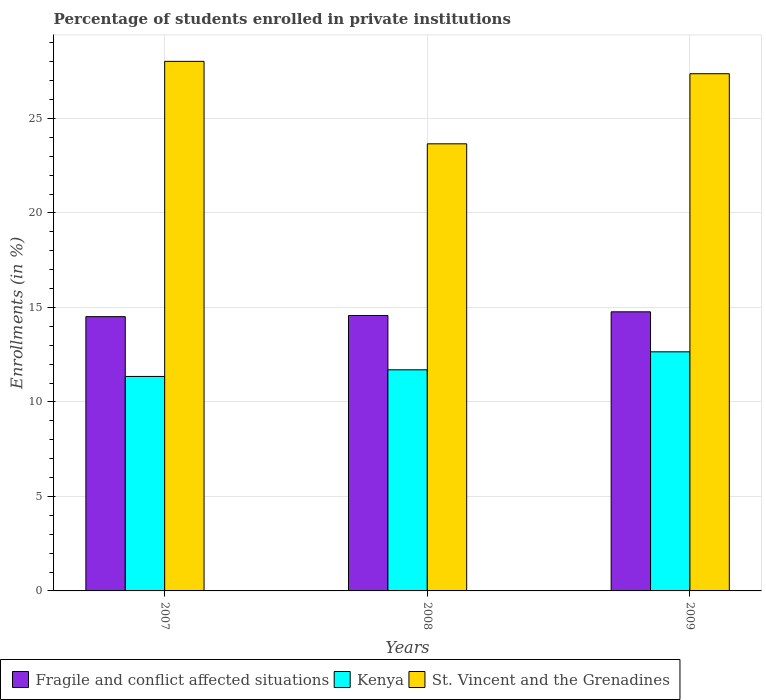How many different coloured bars are there?
Your answer should be very brief. 3. How many groups of bars are there?
Make the answer very short. 3. What is the label of the 2nd group of bars from the left?
Offer a terse response. 2008. What is the percentage of trained teachers in Kenya in 2008?
Ensure brevity in your answer.  11.7. Across all years, what is the maximum percentage of trained teachers in St. Vincent and the Grenadines?
Give a very brief answer. 28.02. Across all years, what is the minimum percentage of trained teachers in Kenya?
Your answer should be very brief. 11.35. In which year was the percentage of trained teachers in Fragile and conflict affected situations maximum?
Offer a terse response. 2009. In which year was the percentage of trained teachers in St. Vincent and the Grenadines minimum?
Offer a terse response. 2008. What is the total percentage of trained teachers in Fragile and conflict affected situations in the graph?
Ensure brevity in your answer.  43.85. What is the difference between the percentage of trained teachers in Fragile and conflict affected situations in 2008 and that in 2009?
Provide a short and direct response. -0.2. What is the difference between the percentage of trained teachers in Kenya in 2008 and the percentage of trained teachers in St. Vincent and the Grenadines in 2009?
Make the answer very short. -15.67. What is the average percentage of trained teachers in Kenya per year?
Offer a very short reply. 11.9. In the year 2009, what is the difference between the percentage of trained teachers in St. Vincent and the Grenadines and percentage of trained teachers in Fragile and conflict affected situations?
Provide a short and direct response. 12.6. What is the ratio of the percentage of trained teachers in Kenya in 2007 to that in 2009?
Provide a short and direct response. 0.9. Is the percentage of trained teachers in St. Vincent and the Grenadines in 2008 less than that in 2009?
Give a very brief answer. Yes. Is the difference between the percentage of trained teachers in St. Vincent and the Grenadines in 2007 and 2008 greater than the difference between the percentage of trained teachers in Fragile and conflict affected situations in 2007 and 2008?
Keep it short and to the point. Yes. What is the difference between the highest and the second highest percentage of trained teachers in Fragile and conflict affected situations?
Provide a succinct answer. 0.2. What is the difference between the highest and the lowest percentage of trained teachers in St. Vincent and the Grenadines?
Provide a succinct answer. 4.36. What does the 3rd bar from the left in 2009 represents?
Make the answer very short. St. Vincent and the Grenadines. What does the 3rd bar from the right in 2009 represents?
Give a very brief answer. Fragile and conflict affected situations. Is it the case that in every year, the sum of the percentage of trained teachers in Fragile and conflict affected situations and percentage of trained teachers in Kenya is greater than the percentage of trained teachers in St. Vincent and the Grenadines?
Give a very brief answer. No. How many bars are there?
Ensure brevity in your answer.  9. How many years are there in the graph?
Your answer should be compact. 3. Where does the legend appear in the graph?
Offer a terse response. Bottom left. How many legend labels are there?
Your answer should be compact. 3. How are the legend labels stacked?
Give a very brief answer. Horizontal. What is the title of the graph?
Provide a succinct answer. Percentage of students enrolled in private institutions. What is the label or title of the Y-axis?
Make the answer very short. Enrollments (in %). What is the Enrollments (in %) in Fragile and conflict affected situations in 2007?
Your answer should be compact. 14.51. What is the Enrollments (in %) of Kenya in 2007?
Offer a very short reply. 11.35. What is the Enrollments (in %) of St. Vincent and the Grenadines in 2007?
Your answer should be very brief. 28.02. What is the Enrollments (in %) of Fragile and conflict affected situations in 2008?
Offer a very short reply. 14.57. What is the Enrollments (in %) in Kenya in 2008?
Provide a succinct answer. 11.7. What is the Enrollments (in %) of St. Vincent and the Grenadines in 2008?
Keep it short and to the point. 23.66. What is the Enrollments (in %) in Fragile and conflict affected situations in 2009?
Your response must be concise. 14.77. What is the Enrollments (in %) in Kenya in 2009?
Make the answer very short. 12.65. What is the Enrollments (in %) of St. Vincent and the Grenadines in 2009?
Give a very brief answer. 27.37. Across all years, what is the maximum Enrollments (in %) of Fragile and conflict affected situations?
Your answer should be compact. 14.77. Across all years, what is the maximum Enrollments (in %) of Kenya?
Offer a terse response. 12.65. Across all years, what is the maximum Enrollments (in %) of St. Vincent and the Grenadines?
Offer a terse response. 28.02. Across all years, what is the minimum Enrollments (in %) in Fragile and conflict affected situations?
Offer a very short reply. 14.51. Across all years, what is the minimum Enrollments (in %) in Kenya?
Provide a succinct answer. 11.35. Across all years, what is the minimum Enrollments (in %) in St. Vincent and the Grenadines?
Provide a succinct answer. 23.66. What is the total Enrollments (in %) in Fragile and conflict affected situations in the graph?
Give a very brief answer. 43.85. What is the total Enrollments (in %) in Kenya in the graph?
Provide a succinct answer. 35.7. What is the total Enrollments (in %) of St. Vincent and the Grenadines in the graph?
Offer a terse response. 79.05. What is the difference between the Enrollments (in %) of Fragile and conflict affected situations in 2007 and that in 2008?
Ensure brevity in your answer.  -0.06. What is the difference between the Enrollments (in %) of Kenya in 2007 and that in 2008?
Provide a short and direct response. -0.35. What is the difference between the Enrollments (in %) of St. Vincent and the Grenadines in 2007 and that in 2008?
Your answer should be very brief. 4.36. What is the difference between the Enrollments (in %) in Fragile and conflict affected situations in 2007 and that in 2009?
Your response must be concise. -0.26. What is the difference between the Enrollments (in %) of Kenya in 2007 and that in 2009?
Your answer should be compact. -1.3. What is the difference between the Enrollments (in %) of St. Vincent and the Grenadines in 2007 and that in 2009?
Make the answer very short. 0.65. What is the difference between the Enrollments (in %) of Fragile and conflict affected situations in 2008 and that in 2009?
Provide a short and direct response. -0.2. What is the difference between the Enrollments (in %) of Kenya in 2008 and that in 2009?
Offer a terse response. -0.95. What is the difference between the Enrollments (in %) in St. Vincent and the Grenadines in 2008 and that in 2009?
Your answer should be compact. -3.71. What is the difference between the Enrollments (in %) of Fragile and conflict affected situations in 2007 and the Enrollments (in %) of Kenya in 2008?
Make the answer very short. 2.81. What is the difference between the Enrollments (in %) in Fragile and conflict affected situations in 2007 and the Enrollments (in %) in St. Vincent and the Grenadines in 2008?
Provide a succinct answer. -9.15. What is the difference between the Enrollments (in %) of Kenya in 2007 and the Enrollments (in %) of St. Vincent and the Grenadines in 2008?
Give a very brief answer. -12.31. What is the difference between the Enrollments (in %) in Fragile and conflict affected situations in 2007 and the Enrollments (in %) in Kenya in 2009?
Keep it short and to the point. 1.86. What is the difference between the Enrollments (in %) of Fragile and conflict affected situations in 2007 and the Enrollments (in %) of St. Vincent and the Grenadines in 2009?
Ensure brevity in your answer.  -12.85. What is the difference between the Enrollments (in %) in Kenya in 2007 and the Enrollments (in %) in St. Vincent and the Grenadines in 2009?
Give a very brief answer. -16.02. What is the difference between the Enrollments (in %) of Fragile and conflict affected situations in 2008 and the Enrollments (in %) of Kenya in 2009?
Give a very brief answer. 1.92. What is the difference between the Enrollments (in %) in Fragile and conflict affected situations in 2008 and the Enrollments (in %) in St. Vincent and the Grenadines in 2009?
Make the answer very short. -12.79. What is the difference between the Enrollments (in %) of Kenya in 2008 and the Enrollments (in %) of St. Vincent and the Grenadines in 2009?
Keep it short and to the point. -15.67. What is the average Enrollments (in %) in Fragile and conflict affected situations per year?
Offer a very short reply. 14.62. What is the average Enrollments (in %) of Kenya per year?
Offer a terse response. 11.9. What is the average Enrollments (in %) in St. Vincent and the Grenadines per year?
Offer a terse response. 26.35. In the year 2007, what is the difference between the Enrollments (in %) of Fragile and conflict affected situations and Enrollments (in %) of Kenya?
Make the answer very short. 3.16. In the year 2007, what is the difference between the Enrollments (in %) of Fragile and conflict affected situations and Enrollments (in %) of St. Vincent and the Grenadines?
Provide a short and direct response. -13.51. In the year 2007, what is the difference between the Enrollments (in %) in Kenya and Enrollments (in %) in St. Vincent and the Grenadines?
Give a very brief answer. -16.67. In the year 2008, what is the difference between the Enrollments (in %) of Fragile and conflict affected situations and Enrollments (in %) of Kenya?
Give a very brief answer. 2.87. In the year 2008, what is the difference between the Enrollments (in %) in Fragile and conflict affected situations and Enrollments (in %) in St. Vincent and the Grenadines?
Give a very brief answer. -9.09. In the year 2008, what is the difference between the Enrollments (in %) of Kenya and Enrollments (in %) of St. Vincent and the Grenadines?
Offer a terse response. -11.96. In the year 2009, what is the difference between the Enrollments (in %) of Fragile and conflict affected situations and Enrollments (in %) of Kenya?
Provide a short and direct response. 2.12. In the year 2009, what is the difference between the Enrollments (in %) of Fragile and conflict affected situations and Enrollments (in %) of St. Vincent and the Grenadines?
Make the answer very short. -12.6. In the year 2009, what is the difference between the Enrollments (in %) of Kenya and Enrollments (in %) of St. Vincent and the Grenadines?
Your answer should be very brief. -14.72. What is the ratio of the Enrollments (in %) in Fragile and conflict affected situations in 2007 to that in 2008?
Your answer should be compact. 1. What is the ratio of the Enrollments (in %) of Kenya in 2007 to that in 2008?
Offer a terse response. 0.97. What is the ratio of the Enrollments (in %) in St. Vincent and the Grenadines in 2007 to that in 2008?
Offer a very short reply. 1.18. What is the ratio of the Enrollments (in %) of Fragile and conflict affected situations in 2007 to that in 2009?
Offer a terse response. 0.98. What is the ratio of the Enrollments (in %) in Kenya in 2007 to that in 2009?
Keep it short and to the point. 0.9. What is the ratio of the Enrollments (in %) in St. Vincent and the Grenadines in 2007 to that in 2009?
Give a very brief answer. 1.02. What is the ratio of the Enrollments (in %) of Fragile and conflict affected situations in 2008 to that in 2009?
Your answer should be compact. 0.99. What is the ratio of the Enrollments (in %) of Kenya in 2008 to that in 2009?
Your response must be concise. 0.92. What is the ratio of the Enrollments (in %) of St. Vincent and the Grenadines in 2008 to that in 2009?
Your answer should be very brief. 0.86. What is the difference between the highest and the second highest Enrollments (in %) in Fragile and conflict affected situations?
Your answer should be compact. 0.2. What is the difference between the highest and the second highest Enrollments (in %) of Kenya?
Make the answer very short. 0.95. What is the difference between the highest and the second highest Enrollments (in %) in St. Vincent and the Grenadines?
Keep it short and to the point. 0.65. What is the difference between the highest and the lowest Enrollments (in %) in Fragile and conflict affected situations?
Offer a very short reply. 0.26. What is the difference between the highest and the lowest Enrollments (in %) in Kenya?
Keep it short and to the point. 1.3. What is the difference between the highest and the lowest Enrollments (in %) of St. Vincent and the Grenadines?
Your answer should be very brief. 4.36. 